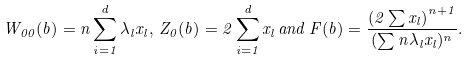Convert formula to latex. <formula><loc_0><loc_0><loc_500><loc_500>W _ { 0 0 } ( b ) = n \sum _ { i = 1 } ^ { d } \lambda _ { l } x _ { l } , \, Z _ { 0 } ( b ) = 2 \sum _ { i = 1 } ^ { d } x _ { l } \, a n d \, F ( b ) = \frac { \left ( 2 \sum x _ { l } \right ) ^ { n + 1 } } { ( \sum n \lambda _ { l } x _ { l } ) ^ { n } } .</formula> 